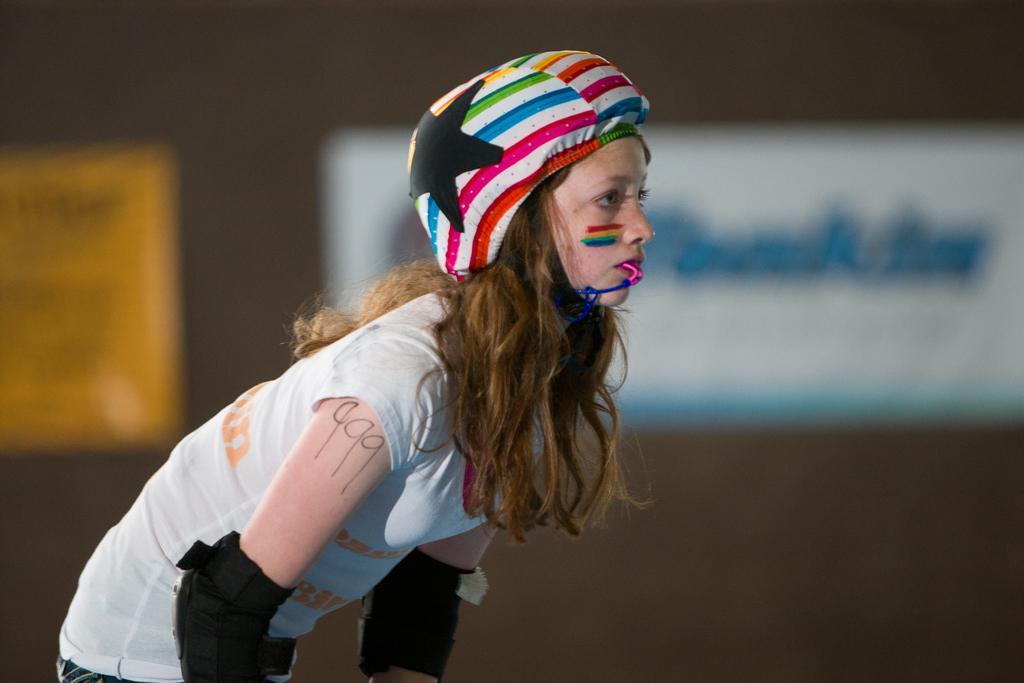Please provide a concise description of this image. In this image I can see a woman. The woman is wearing a helmet, white color t shirt and elbow pads. The background of the image is blurred. 